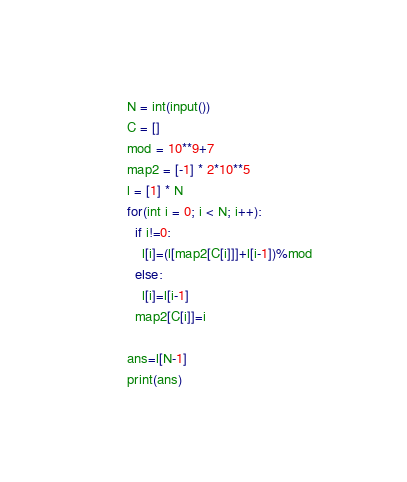Convert code to text. <code><loc_0><loc_0><loc_500><loc_500><_Python_>N = int(input())
C = []
mod = 10**9+7
map2 = [-1] * 2*10**5
l = [1] * N
for(int i = 0; i < N; i++):
  if i!=0:
    l[i]=(l[map2[C[i]]]+l[i-1])%mod
  else:
    l[i]=l[i-1]
  map2[C[i]]=i

ans=l[N-1]
print(ans)</code> 